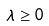Convert formula to latex. <formula><loc_0><loc_0><loc_500><loc_500>\lambda \geq 0</formula> 